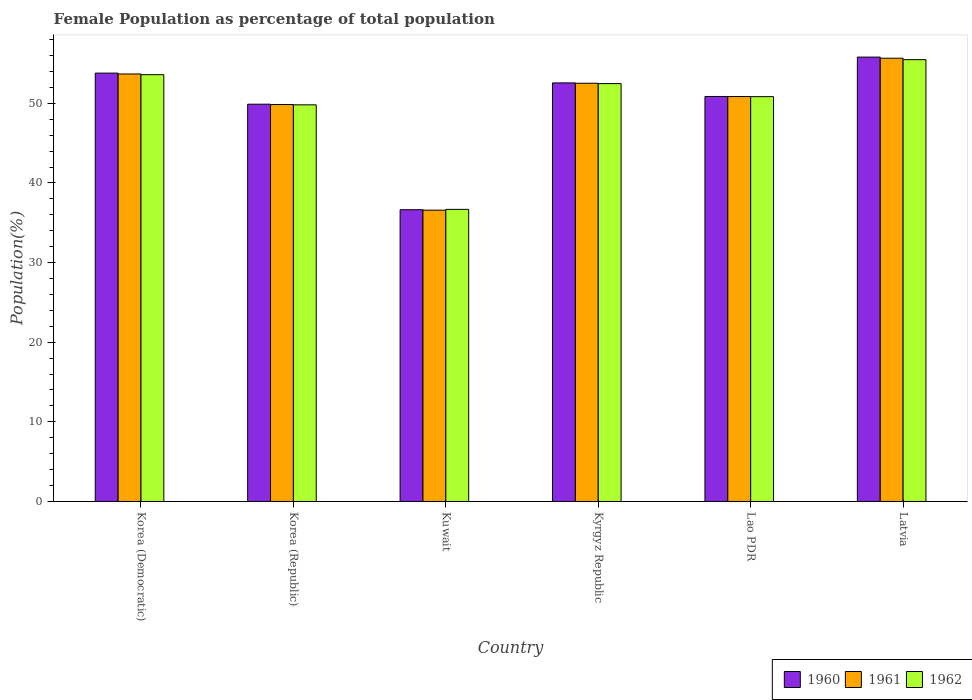How many different coloured bars are there?
Keep it short and to the point. 3. Are the number of bars per tick equal to the number of legend labels?
Offer a very short reply. Yes. How many bars are there on the 3rd tick from the left?
Provide a short and direct response. 3. What is the label of the 6th group of bars from the left?
Your answer should be very brief. Latvia. What is the female population in in 1961 in Korea (Republic)?
Provide a succinct answer. 49.85. Across all countries, what is the maximum female population in in 1962?
Your response must be concise. 55.48. Across all countries, what is the minimum female population in in 1960?
Provide a short and direct response. 36.64. In which country was the female population in in 1960 maximum?
Provide a succinct answer. Latvia. In which country was the female population in in 1961 minimum?
Offer a very short reply. Kuwait. What is the total female population in in 1960 in the graph?
Make the answer very short. 299.53. What is the difference between the female population in in 1961 in Kuwait and that in Lao PDR?
Ensure brevity in your answer.  -14.27. What is the difference between the female population in in 1962 in Latvia and the female population in in 1961 in Korea (Republic)?
Your answer should be very brief. 5.64. What is the average female population in in 1960 per country?
Provide a succinct answer. 49.92. What is the difference between the female population in of/in 1960 and female population in of/in 1962 in Kyrgyz Republic?
Provide a short and direct response. 0.09. In how many countries, is the female population in in 1961 greater than 52 %?
Provide a short and direct response. 3. What is the ratio of the female population in in 1960 in Korea (Democratic) to that in Lao PDR?
Your answer should be compact. 1.06. Is the difference between the female population in in 1960 in Korea (Republic) and Kyrgyz Republic greater than the difference between the female population in in 1962 in Korea (Republic) and Kyrgyz Republic?
Your answer should be very brief. No. What is the difference between the highest and the second highest female population in in 1962?
Give a very brief answer. -1.12. What is the difference between the highest and the lowest female population in in 1961?
Ensure brevity in your answer.  19.08. Is the sum of the female population in in 1960 in Korea (Democratic) and Korea (Republic) greater than the maximum female population in in 1962 across all countries?
Your response must be concise. Yes. What does the 3rd bar from the left in Kuwait represents?
Your answer should be very brief. 1962. What does the 3rd bar from the right in Korea (Democratic) represents?
Offer a very short reply. 1960. Is it the case that in every country, the sum of the female population in in 1960 and female population in in 1962 is greater than the female population in in 1961?
Your answer should be very brief. Yes. What is the difference between two consecutive major ticks on the Y-axis?
Your response must be concise. 10. Are the values on the major ticks of Y-axis written in scientific E-notation?
Your answer should be very brief. No. Where does the legend appear in the graph?
Make the answer very short. Bottom right. How are the legend labels stacked?
Give a very brief answer. Horizontal. What is the title of the graph?
Offer a terse response. Female Population as percentage of total population. What is the label or title of the Y-axis?
Provide a short and direct response. Population(%). What is the Population(%) in 1960 in Korea (Democratic)?
Ensure brevity in your answer.  53.79. What is the Population(%) of 1961 in Korea (Democratic)?
Offer a terse response. 53.68. What is the Population(%) in 1962 in Korea (Democratic)?
Provide a succinct answer. 53.59. What is the Population(%) in 1960 in Korea (Republic)?
Provide a succinct answer. 49.89. What is the Population(%) of 1961 in Korea (Republic)?
Give a very brief answer. 49.85. What is the Population(%) of 1962 in Korea (Republic)?
Keep it short and to the point. 49.81. What is the Population(%) of 1960 in Kuwait?
Make the answer very short. 36.64. What is the Population(%) of 1961 in Kuwait?
Provide a short and direct response. 36.58. What is the Population(%) of 1962 in Kuwait?
Your answer should be compact. 36.68. What is the Population(%) in 1960 in Kyrgyz Republic?
Give a very brief answer. 52.56. What is the Population(%) of 1961 in Kyrgyz Republic?
Give a very brief answer. 52.52. What is the Population(%) of 1962 in Kyrgyz Republic?
Your answer should be very brief. 52.47. What is the Population(%) of 1960 in Lao PDR?
Make the answer very short. 50.86. What is the Population(%) of 1961 in Lao PDR?
Provide a short and direct response. 50.85. What is the Population(%) in 1962 in Lao PDR?
Keep it short and to the point. 50.84. What is the Population(%) in 1960 in Latvia?
Ensure brevity in your answer.  55.8. What is the Population(%) of 1961 in Latvia?
Provide a short and direct response. 55.66. What is the Population(%) of 1962 in Latvia?
Your answer should be very brief. 55.48. Across all countries, what is the maximum Population(%) of 1960?
Give a very brief answer. 55.8. Across all countries, what is the maximum Population(%) of 1961?
Provide a short and direct response. 55.66. Across all countries, what is the maximum Population(%) in 1962?
Your answer should be compact. 55.48. Across all countries, what is the minimum Population(%) in 1960?
Give a very brief answer. 36.64. Across all countries, what is the minimum Population(%) of 1961?
Give a very brief answer. 36.58. Across all countries, what is the minimum Population(%) of 1962?
Ensure brevity in your answer.  36.68. What is the total Population(%) in 1960 in the graph?
Make the answer very short. 299.53. What is the total Population(%) in 1961 in the graph?
Provide a succinct answer. 299.13. What is the total Population(%) in 1962 in the graph?
Your response must be concise. 298.87. What is the difference between the Population(%) in 1960 in Korea (Democratic) and that in Korea (Republic)?
Offer a very short reply. 3.9. What is the difference between the Population(%) in 1961 in Korea (Democratic) and that in Korea (Republic)?
Keep it short and to the point. 3.84. What is the difference between the Population(%) in 1962 in Korea (Democratic) and that in Korea (Republic)?
Your answer should be compact. 3.79. What is the difference between the Population(%) of 1960 in Korea (Democratic) and that in Kuwait?
Your response must be concise. 17.15. What is the difference between the Population(%) of 1961 in Korea (Democratic) and that in Kuwait?
Make the answer very short. 17.1. What is the difference between the Population(%) of 1962 in Korea (Democratic) and that in Kuwait?
Your answer should be very brief. 16.91. What is the difference between the Population(%) of 1960 in Korea (Democratic) and that in Kyrgyz Republic?
Your response must be concise. 1.23. What is the difference between the Population(%) in 1961 in Korea (Democratic) and that in Kyrgyz Republic?
Your answer should be compact. 1.16. What is the difference between the Population(%) of 1962 in Korea (Democratic) and that in Kyrgyz Republic?
Keep it short and to the point. 1.12. What is the difference between the Population(%) in 1960 in Korea (Democratic) and that in Lao PDR?
Ensure brevity in your answer.  2.93. What is the difference between the Population(%) of 1961 in Korea (Democratic) and that in Lao PDR?
Your response must be concise. 2.83. What is the difference between the Population(%) of 1962 in Korea (Democratic) and that in Lao PDR?
Provide a short and direct response. 2.76. What is the difference between the Population(%) of 1960 in Korea (Democratic) and that in Latvia?
Make the answer very short. -2.01. What is the difference between the Population(%) of 1961 in Korea (Democratic) and that in Latvia?
Your answer should be very brief. -1.98. What is the difference between the Population(%) of 1962 in Korea (Democratic) and that in Latvia?
Provide a short and direct response. -1.89. What is the difference between the Population(%) of 1960 in Korea (Republic) and that in Kuwait?
Your answer should be compact. 13.25. What is the difference between the Population(%) in 1961 in Korea (Republic) and that in Kuwait?
Your answer should be very brief. 13.27. What is the difference between the Population(%) in 1962 in Korea (Republic) and that in Kuwait?
Offer a very short reply. 13.13. What is the difference between the Population(%) of 1960 in Korea (Republic) and that in Kyrgyz Republic?
Your response must be concise. -2.67. What is the difference between the Population(%) in 1961 in Korea (Republic) and that in Kyrgyz Republic?
Your answer should be compact. -2.67. What is the difference between the Population(%) in 1962 in Korea (Republic) and that in Kyrgyz Republic?
Provide a succinct answer. -2.67. What is the difference between the Population(%) in 1960 in Korea (Republic) and that in Lao PDR?
Make the answer very short. -0.97. What is the difference between the Population(%) of 1961 in Korea (Republic) and that in Lao PDR?
Your answer should be compact. -1. What is the difference between the Population(%) of 1962 in Korea (Republic) and that in Lao PDR?
Ensure brevity in your answer.  -1.03. What is the difference between the Population(%) in 1960 in Korea (Republic) and that in Latvia?
Offer a very short reply. -5.92. What is the difference between the Population(%) in 1961 in Korea (Republic) and that in Latvia?
Provide a short and direct response. -5.81. What is the difference between the Population(%) of 1962 in Korea (Republic) and that in Latvia?
Offer a very short reply. -5.68. What is the difference between the Population(%) in 1960 in Kuwait and that in Kyrgyz Republic?
Offer a very short reply. -15.93. What is the difference between the Population(%) of 1961 in Kuwait and that in Kyrgyz Republic?
Your answer should be compact. -15.94. What is the difference between the Population(%) in 1962 in Kuwait and that in Kyrgyz Republic?
Your answer should be compact. -15.79. What is the difference between the Population(%) of 1960 in Kuwait and that in Lao PDR?
Give a very brief answer. -14.22. What is the difference between the Population(%) of 1961 in Kuwait and that in Lao PDR?
Your response must be concise. -14.27. What is the difference between the Population(%) in 1962 in Kuwait and that in Lao PDR?
Your answer should be very brief. -14.15. What is the difference between the Population(%) of 1960 in Kuwait and that in Latvia?
Offer a very short reply. -19.17. What is the difference between the Population(%) of 1961 in Kuwait and that in Latvia?
Ensure brevity in your answer.  -19.08. What is the difference between the Population(%) in 1962 in Kuwait and that in Latvia?
Make the answer very short. -18.8. What is the difference between the Population(%) in 1960 in Kyrgyz Republic and that in Lao PDR?
Your answer should be very brief. 1.7. What is the difference between the Population(%) in 1961 in Kyrgyz Republic and that in Lao PDR?
Your answer should be compact. 1.67. What is the difference between the Population(%) of 1962 in Kyrgyz Republic and that in Lao PDR?
Give a very brief answer. 1.64. What is the difference between the Population(%) of 1960 in Kyrgyz Republic and that in Latvia?
Keep it short and to the point. -3.24. What is the difference between the Population(%) in 1961 in Kyrgyz Republic and that in Latvia?
Keep it short and to the point. -3.14. What is the difference between the Population(%) in 1962 in Kyrgyz Republic and that in Latvia?
Your answer should be very brief. -3.01. What is the difference between the Population(%) of 1960 in Lao PDR and that in Latvia?
Offer a very short reply. -4.94. What is the difference between the Population(%) of 1961 in Lao PDR and that in Latvia?
Offer a very short reply. -4.81. What is the difference between the Population(%) in 1962 in Lao PDR and that in Latvia?
Give a very brief answer. -4.65. What is the difference between the Population(%) in 1960 in Korea (Democratic) and the Population(%) in 1961 in Korea (Republic)?
Your response must be concise. 3.94. What is the difference between the Population(%) in 1960 in Korea (Democratic) and the Population(%) in 1962 in Korea (Republic)?
Offer a very short reply. 3.98. What is the difference between the Population(%) of 1961 in Korea (Democratic) and the Population(%) of 1962 in Korea (Republic)?
Your answer should be compact. 3.87. What is the difference between the Population(%) in 1960 in Korea (Democratic) and the Population(%) in 1961 in Kuwait?
Your answer should be compact. 17.21. What is the difference between the Population(%) in 1960 in Korea (Democratic) and the Population(%) in 1962 in Kuwait?
Your answer should be very brief. 17.11. What is the difference between the Population(%) of 1961 in Korea (Democratic) and the Population(%) of 1962 in Kuwait?
Make the answer very short. 17. What is the difference between the Population(%) in 1960 in Korea (Democratic) and the Population(%) in 1961 in Kyrgyz Republic?
Provide a succinct answer. 1.27. What is the difference between the Population(%) in 1960 in Korea (Democratic) and the Population(%) in 1962 in Kyrgyz Republic?
Your answer should be compact. 1.32. What is the difference between the Population(%) of 1961 in Korea (Democratic) and the Population(%) of 1962 in Kyrgyz Republic?
Your answer should be very brief. 1.21. What is the difference between the Population(%) of 1960 in Korea (Democratic) and the Population(%) of 1961 in Lao PDR?
Provide a short and direct response. 2.94. What is the difference between the Population(%) of 1960 in Korea (Democratic) and the Population(%) of 1962 in Lao PDR?
Ensure brevity in your answer.  2.95. What is the difference between the Population(%) of 1961 in Korea (Democratic) and the Population(%) of 1962 in Lao PDR?
Your response must be concise. 2.85. What is the difference between the Population(%) of 1960 in Korea (Democratic) and the Population(%) of 1961 in Latvia?
Provide a short and direct response. -1.87. What is the difference between the Population(%) in 1960 in Korea (Democratic) and the Population(%) in 1962 in Latvia?
Give a very brief answer. -1.69. What is the difference between the Population(%) of 1961 in Korea (Democratic) and the Population(%) of 1962 in Latvia?
Keep it short and to the point. -1.8. What is the difference between the Population(%) in 1960 in Korea (Republic) and the Population(%) in 1961 in Kuwait?
Keep it short and to the point. 13.31. What is the difference between the Population(%) of 1960 in Korea (Republic) and the Population(%) of 1962 in Kuwait?
Provide a short and direct response. 13.21. What is the difference between the Population(%) in 1961 in Korea (Republic) and the Population(%) in 1962 in Kuwait?
Make the answer very short. 13.16. What is the difference between the Population(%) of 1960 in Korea (Republic) and the Population(%) of 1961 in Kyrgyz Republic?
Keep it short and to the point. -2.63. What is the difference between the Population(%) in 1960 in Korea (Republic) and the Population(%) in 1962 in Kyrgyz Republic?
Keep it short and to the point. -2.59. What is the difference between the Population(%) of 1961 in Korea (Republic) and the Population(%) of 1962 in Kyrgyz Republic?
Your answer should be compact. -2.63. What is the difference between the Population(%) in 1960 in Korea (Republic) and the Population(%) in 1961 in Lao PDR?
Provide a short and direct response. -0.96. What is the difference between the Population(%) in 1960 in Korea (Republic) and the Population(%) in 1962 in Lao PDR?
Offer a terse response. -0.95. What is the difference between the Population(%) in 1961 in Korea (Republic) and the Population(%) in 1962 in Lao PDR?
Offer a terse response. -0.99. What is the difference between the Population(%) in 1960 in Korea (Republic) and the Population(%) in 1961 in Latvia?
Make the answer very short. -5.77. What is the difference between the Population(%) of 1960 in Korea (Republic) and the Population(%) of 1962 in Latvia?
Keep it short and to the point. -5.6. What is the difference between the Population(%) of 1961 in Korea (Republic) and the Population(%) of 1962 in Latvia?
Ensure brevity in your answer.  -5.64. What is the difference between the Population(%) in 1960 in Kuwait and the Population(%) in 1961 in Kyrgyz Republic?
Provide a succinct answer. -15.88. What is the difference between the Population(%) of 1960 in Kuwait and the Population(%) of 1962 in Kyrgyz Republic?
Your response must be concise. -15.84. What is the difference between the Population(%) in 1961 in Kuwait and the Population(%) in 1962 in Kyrgyz Republic?
Give a very brief answer. -15.89. What is the difference between the Population(%) in 1960 in Kuwait and the Population(%) in 1961 in Lao PDR?
Keep it short and to the point. -14.21. What is the difference between the Population(%) of 1960 in Kuwait and the Population(%) of 1962 in Lao PDR?
Ensure brevity in your answer.  -14.2. What is the difference between the Population(%) of 1961 in Kuwait and the Population(%) of 1962 in Lao PDR?
Your response must be concise. -14.26. What is the difference between the Population(%) in 1960 in Kuwait and the Population(%) in 1961 in Latvia?
Ensure brevity in your answer.  -19.02. What is the difference between the Population(%) of 1960 in Kuwait and the Population(%) of 1962 in Latvia?
Ensure brevity in your answer.  -18.85. What is the difference between the Population(%) of 1961 in Kuwait and the Population(%) of 1962 in Latvia?
Your answer should be very brief. -18.9. What is the difference between the Population(%) in 1960 in Kyrgyz Republic and the Population(%) in 1961 in Lao PDR?
Provide a short and direct response. 1.71. What is the difference between the Population(%) in 1960 in Kyrgyz Republic and the Population(%) in 1962 in Lao PDR?
Offer a terse response. 1.73. What is the difference between the Population(%) of 1961 in Kyrgyz Republic and the Population(%) of 1962 in Lao PDR?
Offer a terse response. 1.68. What is the difference between the Population(%) of 1960 in Kyrgyz Republic and the Population(%) of 1961 in Latvia?
Provide a short and direct response. -3.1. What is the difference between the Population(%) of 1960 in Kyrgyz Republic and the Population(%) of 1962 in Latvia?
Offer a very short reply. -2.92. What is the difference between the Population(%) in 1961 in Kyrgyz Republic and the Population(%) in 1962 in Latvia?
Your answer should be very brief. -2.96. What is the difference between the Population(%) in 1960 in Lao PDR and the Population(%) in 1961 in Latvia?
Provide a succinct answer. -4.8. What is the difference between the Population(%) of 1960 in Lao PDR and the Population(%) of 1962 in Latvia?
Offer a very short reply. -4.62. What is the difference between the Population(%) in 1961 in Lao PDR and the Population(%) in 1962 in Latvia?
Your response must be concise. -4.63. What is the average Population(%) of 1960 per country?
Ensure brevity in your answer.  49.92. What is the average Population(%) of 1961 per country?
Make the answer very short. 49.86. What is the average Population(%) of 1962 per country?
Your response must be concise. 49.81. What is the difference between the Population(%) of 1960 and Population(%) of 1961 in Korea (Democratic)?
Your answer should be compact. 0.11. What is the difference between the Population(%) of 1960 and Population(%) of 1962 in Korea (Democratic)?
Provide a short and direct response. 0.2. What is the difference between the Population(%) in 1961 and Population(%) in 1962 in Korea (Democratic)?
Ensure brevity in your answer.  0.09. What is the difference between the Population(%) of 1960 and Population(%) of 1961 in Korea (Republic)?
Provide a succinct answer. 0.04. What is the difference between the Population(%) of 1960 and Population(%) of 1962 in Korea (Republic)?
Provide a short and direct response. 0.08. What is the difference between the Population(%) of 1961 and Population(%) of 1962 in Korea (Republic)?
Your response must be concise. 0.04. What is the difference between the Population(%) of 1960 and Population(%) of 1961 in Kuwait?
Your answer should be very brief. 0.06. What is the difference between the Population(%) of 1960 and Population(%) of 1962 in Kuwait?
Your answer should be very brief. -0.05. What is the difference between the Population(%) of 1961 and Population(%) of 1962 in Kuwait?
Your answer should be very brief. -0.1. What is the difference between the Population(%) in 1960 and Population(%) in 1961 in Kyrgyz Republic?
Your answer should be very brief. 0.04. What is the difference between the Population(%) of 1960 and Population(%) of 1962 in Kyrgyz Republic?
Keep it short and to the point. 0.09. What is the difference between the Population(%) of 1961 and Population(%) of 1962 in Kyrgyz Republic?
Your answer should be compact. 0.05. What is the difference between the Population(%) of 1960 and Population(%) of 1961 in Lao PDR?
Your answer should be compact. 0.01. What is the difference between the Population(%) in 1960 and Population(%) in 1962 in Lao PDR?
Provide a short and direct response. 0.02. What is the difference between the Population(%) of 1961 and Population(%) of 1962 in Lao PDR?
Offer a very short reply. 0.01. What is the difference between the Population(%) of 1960 and Population(%) of 1961 in Latvia?
Your response must be concise. 0.14. What is the difference between the Population(%) of 1960 and Population(%) of 1962 in Latvia?
Make the answer very short. 0.32. What is the difference between the Population(%) in 1961 and Population(%) in 1962 in Latvia?
Your response must be concise. 0.18. What is the ratio of the Population(%) in 1960 in Korea (Democratic) to that in Korea (Republic)?
Your response must be concise. 1.08. What is the ratio of the Population(%) in 1961 in Korea (Democratic) to that in Korea (Republic)?
Keep it short and to the point. 1.08. What is the ratio of the Population(%) in 1962 in Korea (Democratic) to that in Korea (Republic)?
Offer a terse response. 1.08. What is the ratio of the Population(%) of 1960 in Korea (Democratic) to that in Kuwait?
Ensure brevity in your answer.  1.47. What is the ratio of the Population(%) in 1961 in Korea (Democratic) to that in Kuwait?
Ensure brevity in your answer.  1.47. What is the ratio of the Population(%) of 1962 in Korea (Democratic) to that in Kuwait?
Offer a very short reply. 1.46. What is the ratio of the Population(%) in 1960 in Korea (Democratic) to that in Kyrgyz Republic?
Provide a succinct answer. 1.02. What is the ratio of the Population(%) in 1961 in Korea (Democratic) to that in Kyrgyz Republic?
Give a very brief answer. 1.02. What is the ratio of the Population(%) of 1962 in Korea (Democratic) to that in Kyrgyz Republic?
Offer a terse response. 1.02. What is the ratio of the Population(%) of 1960 in Korea (Democratic) to that in Lao PDR?
Provide a succinct answer. 1.06. What is the ratio of the Population(%) in 1961 in Korea (Democratic) to that in Lao PDR?
Your answer should be compact. 1.06. What is the ratio of the Population(%) of 1962 in Korea (Democratic) to that in Lao PDR?
Provide a short and direct response. 1.05. What is the ratio of the Population(%) of 1960 in Korea (Democratic) to that in Latvia?
Offer a terse response. 0.96. What is the ratio of the Population(%) in 1961 in Korea (Democratic) to that in Latvia?
Ensure brevity in your answer.  0.96. What is the ratio of the Population(%) of 1960 in Korea (Republic) to that in Kuwait?
Your response must be concise. 1.36. What is the ratio of the Population(%) in 1961 in Korea (Republic) to that in Kuwait?
Provide a short and direct response. 1.36. What is the ratio of the Population(%) in 1962 in Korea (Republic) to that in Kuwait?
Your response must be concise. 1.36. What is the ratio of the Population(%) of 1960 in Korea (Republic) to that in Kyrgyz Republic?
Your answer should be compact. 0.95. What is the ratio of the Population(%) of 1961 in Korea (Republic) to that in Kyrgyz Republic?
Make the answer very short. 0.95. What is the ratio of the Population(%) of 1962 in Korea (Republic) to that in Kyrgyz Republic?
Your response must be concise. 0.95. What is the ratio of the Population(%) in 1960 in Korea (Republic) to that in Lao PDR?
Your response must be concise. 0.98. What is the ratio of the Population(%) in 1961 in Korea (Republic) to that in Lao PDR?
Your answer should be very brief. 0.98. What is the ratio of the Population(%) in 1962 in Korea (Republic) to that in Lao PDR?
Provide a short and direct response. 0.98. What is the ratio of the Population(%) in 1960 in Korea (Republic) to that in Latvia?
Keep it short and to the point. 0.89. What is the ratio of the Population(%) of 1961 in Korea (Republic) to that in Latvia?
Your answer should be compact. 0.9. What is the ratio of the Population(%) of 1962 in Korea (Republic) to that in Latvia?
Provide a short and direct response. 0.9. What is the ratio of the Population(%) in 1960 in Kuwait to that in Kyrgyz Republic?
Make the answer very short. 0.7. What is the ratio of the Population(%) in 1961 in Kuwait to that in Kyrgyz Republic?
Ensure brevity in your answer.  0.7. What is the ratio of the Population(%) of 1962 in Kuwait to that in Kyrgyz Republic?
Ensure brevity in your answer.  0.7. What is the ratio of the Population(%) in 1960 in Kuwait to that in Lao PDR?
Offer a terse response. 0.72. What is the ratio of the Population(%) of 1961 in Kuwait to that in Lao PDR?
Give a very brief answer. 0.72. What is the ratio of the Population(%) of 1962 in Kuwait to that in Lao PDR?
Provide a succinct answer. 0.72. What is the ratio of the Population(%) of 1960 in Kuwait to that in Latvia?
Provide a succinct answer. 0.66. What is the ratio of the Population(%) in 1961 in Kuwait to that in Latvia?
Offer a very short reply. 0.66. What is the ratio of the Population(%) of 1962 in Kuwait to that in Latvia?
Make the answer very short. 0.66. What is the ratio of the Population(%) in 1960 in Kyrgyz Republic to that in Lao PDR?
Your answer should be very brief. 1.03. What is the ratio of the Population(%) of 1961 in Kyrgyz Republic to that in Lao PDR?
Your answer should be very brief. 1.03. What is the ratio of the Population(%) of 1962 in Kyrgyz Republic to that in Lao PDR?
Your response must be concise. 1.03. What is the ratio of the Population(%) in 1960 in Kyrgyz Republic to that in Latvia?
Your response must be concise. 0.94. What is the ratio of the Population(%) in 1961 in Kyrgyz Republic to that in Latvia?
Make the answer very short. 0.94. What is the ratio of the Population(%) in 1962 in Kyrgyz Republic to that in Latvia?
Your response must be concise. 0.95. What is the ratio of the Population(%) of 1960 in Lao PDR to that in Latvia?
Make the answer very short. 0.91. What is the ratio of the Population(%) in 1961 in Lao PDR to that in Latvia?
Offer a very short reply. 0.91. What is the ratio of the Population(%) of 1962 in Lao PDR to that in Latvia?
Make the answer very short. 0.92. What is the difference between the highest and the second highest Population(%) in 1960?
Provide a succinct answer. 2.01. What is the difference between the highest and the second highest Population(%) of 1961?
Offer a terse response. 1.98. What is the difference between the highest and the second highest Population(%) in 1962?
Keep it short and to the point. 1.89. What is the difference between the highest and the lowest Population(%) of 1960?
Provide a short and direct response. 19.17. What is the difference between the highest and the lowest Population(%) of 1961?
Make the answer very short. 19.08. What is the difference between the highest and the lowest Population(%) of 1962?
Provide a succinct answer. 18.8. 